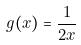Convert formula to latex. <formula><loc_0><loc_0><loc_500><loc_500>g ( x ) = \frac { 1 } { 2 x }</formula> 